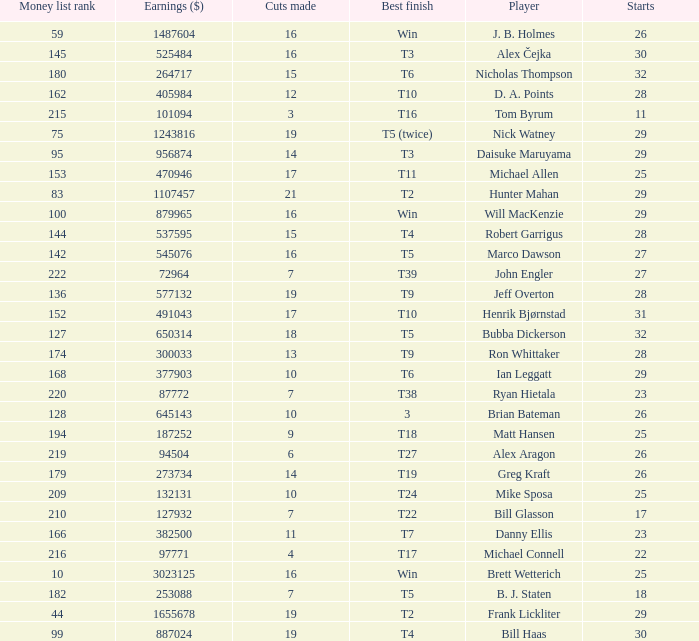What is the minimum number of starts for the players having a best finish of T18? 25.0. 